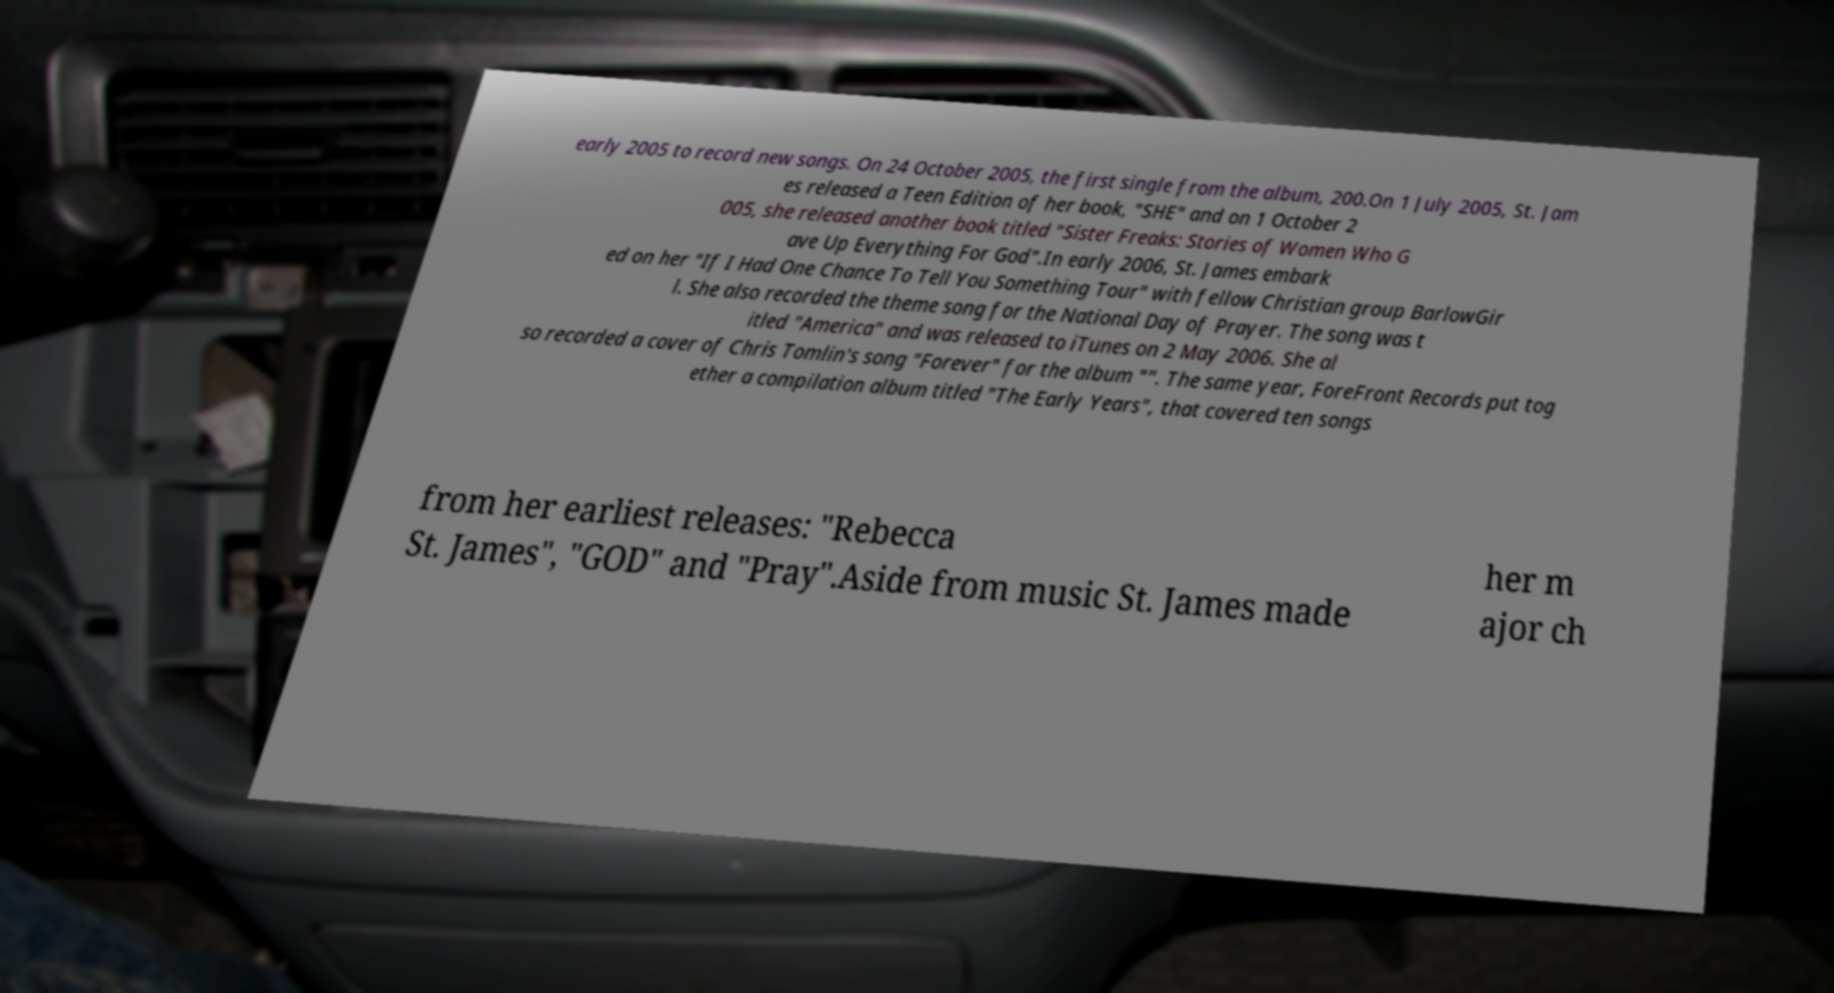I need the written content from this picture converted into text. Can you do that? early 2005 to record new songs. On 24 October 2005, the first single from the album, 200.On 1 July 2005, St. Jam es released a Teen Edition of her book, "SHE" and on 1 October 2 005, she released another book titled "Sister Freaks: Stories of Women Who G ave Up Everything For God".In early 2006, St. James embark ed on her "If I Had One Chance To Tell You Something Tour" with fellow Christian group BarlowGir l. She also recorded the theme song for the National Day of Prayer. The song was t itled "America" and was released to iTunes on 2 May 2006. She al so recorded a cover of Chris Tomlin's song "Forever" for the album "". The same year, ForeFront Records put tog ether a compilation album titled "The Early Years", that covered ten songs from her earliest releases: "Rebecca St. James", "GOD" and "Pray".Aside from music St. James made her m ajor ch 